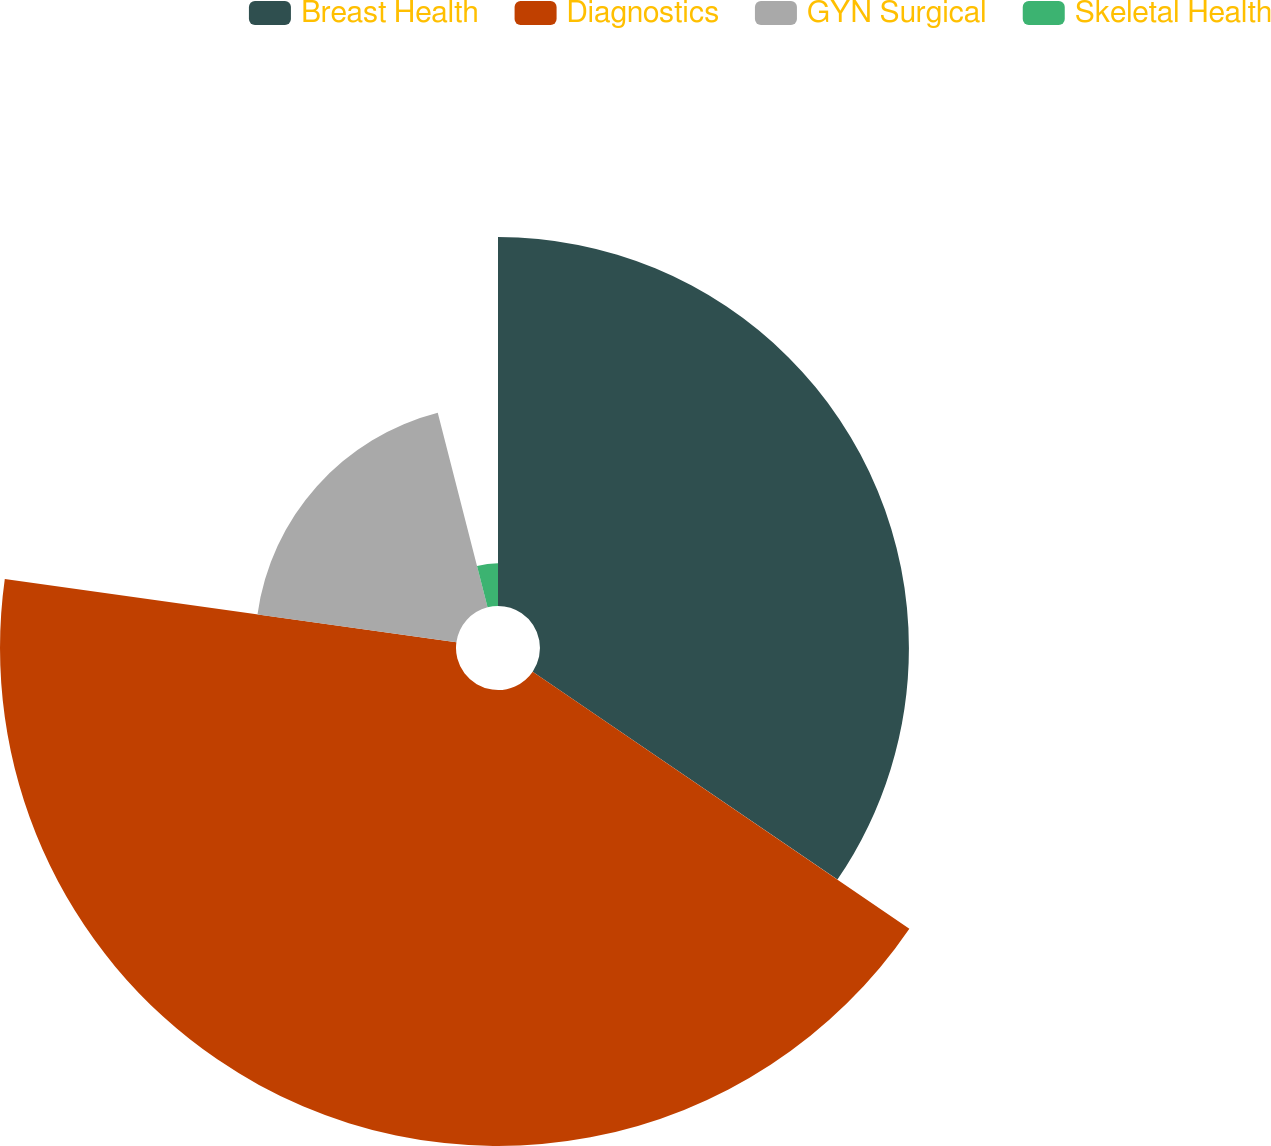Convert chart. <chart><loc_0><loc_0><loc_500><loc_500><pie_chart><fcel>Breast Health<fcel>Diagnostics<fcel>GYN Surgical<fcel>Skeletal Health<nl><fcel>34.53%<fcel>42.68%<fcel>18.8%<fcel>3.99%<nl></chart> 